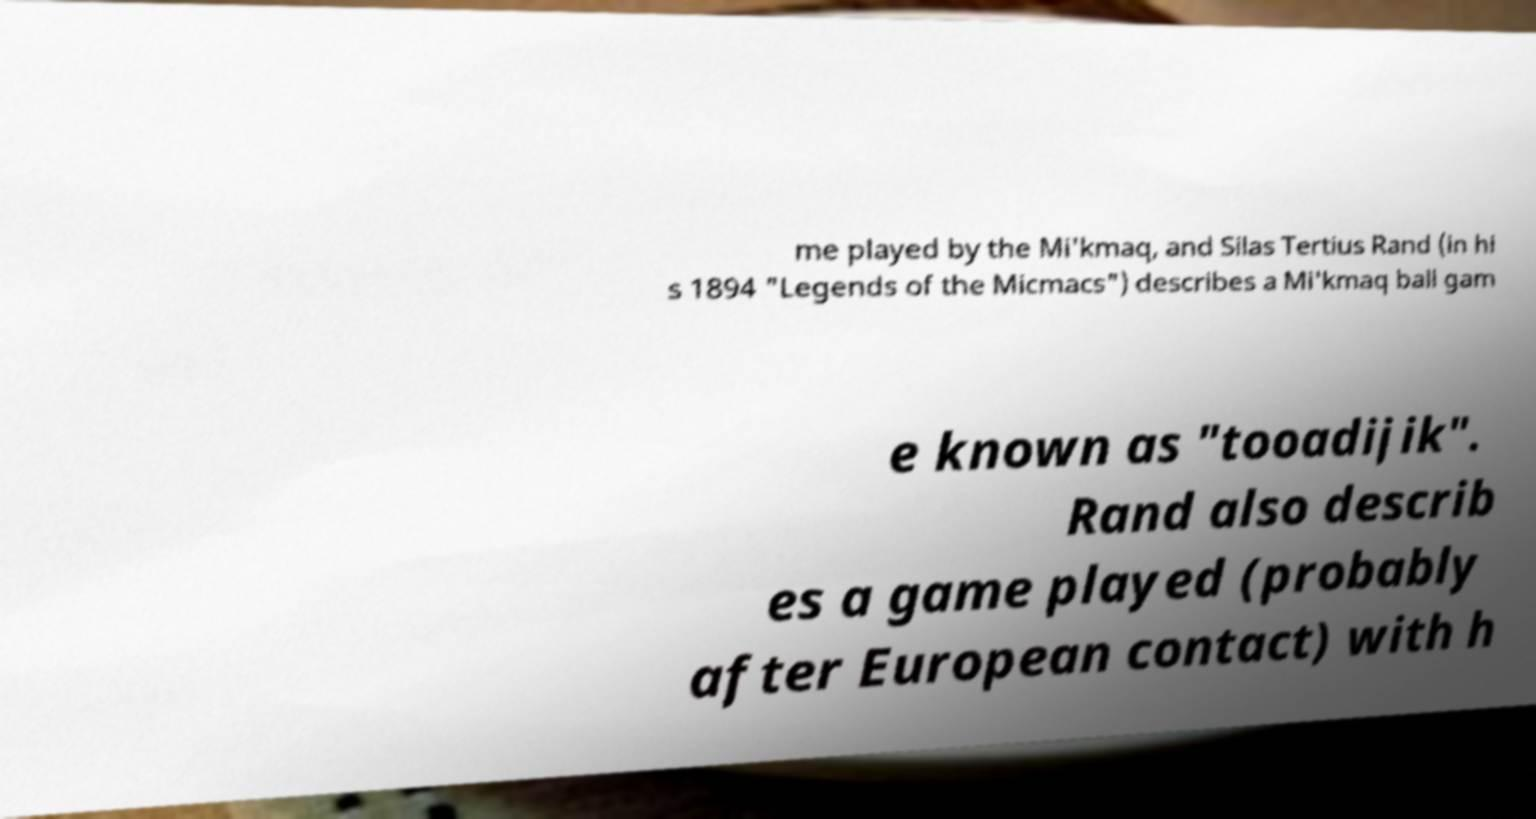Please read and relay the text visible in this image. What does it say? me played by the Mi'kmaq, and Silas Tertius Rand (in hi s 1894 "Legends of the Micmacs") describes a Mi'kmaq ball gam e known as "tooadijik". Rand also describ es a game played (probably after European contact) with h 